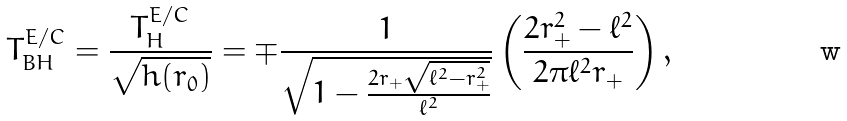Convert formula to latex. <formula><loc_0><loc_0><loc_500><loc_500>T ^ { E / C } _ { B H } = \frac { T _ { H } ^ { E / C } } { \sqrt { h ( r _ { 0 } ) } } = \mp \frac { 1 } { \sqrt { 1 - \frac { 2 r _ { + } \sqrt { \ell ^ { 2 } - r _ { + } ^ { 2 } } } { \ell ^ { 2 } } } } \left ( \frac { 2 r _ { + } ^ { 2 } - \ell ^ { 2 } } { 2 \pi \ell ^ { 2 } r _ { + } } \right ) ,</formula> 